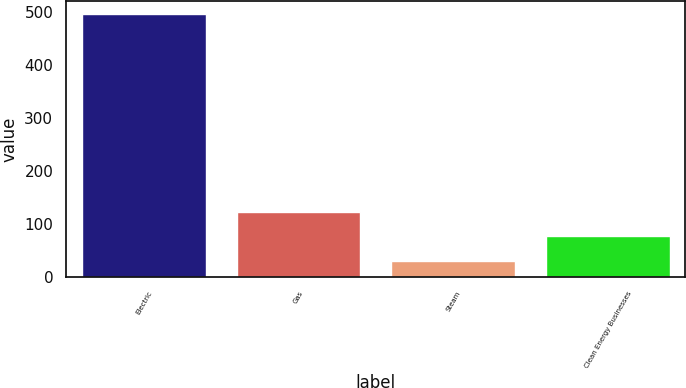Convert chart to OTSL. <chart><loc_0><loc_0><loc_500><loc_500><bar_chart><fcel>Electric<fcel>Gas<fcel>Steam<fcel>Clean Energy Businesses<nl><fcel>495<fcel>123<fcel>30<fcel>76.5<nl></chart> 